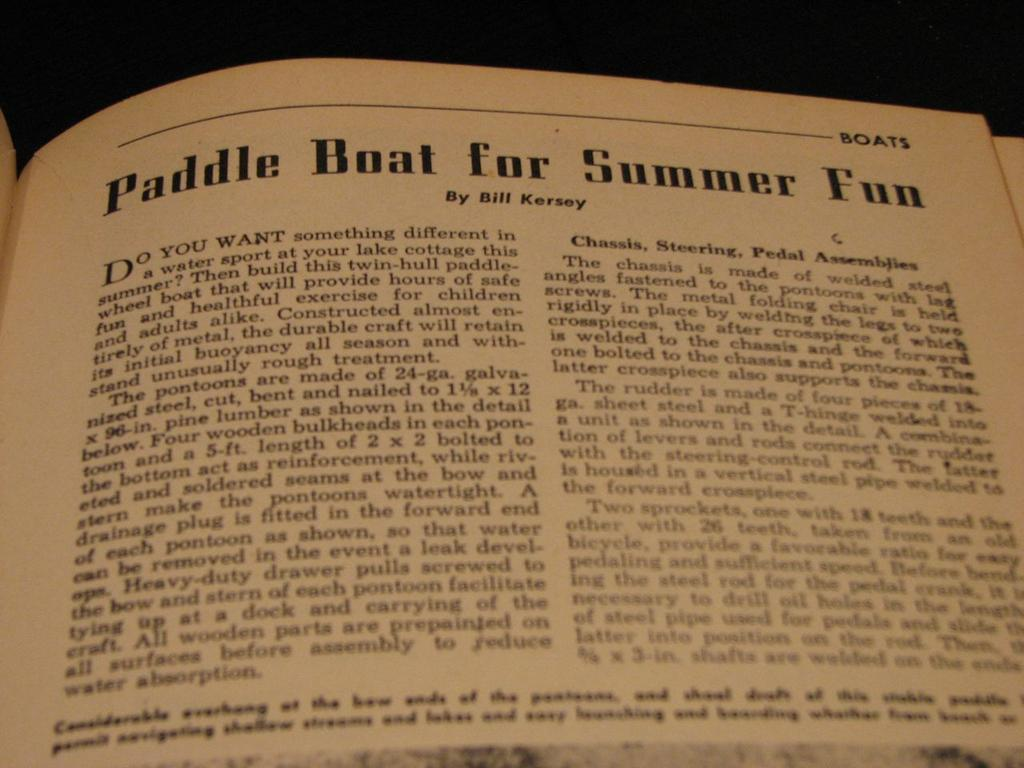<image>
Present a compact description of the photo's key features. A book is opened to a page titled "Paddle Boat for Summer Fun." 